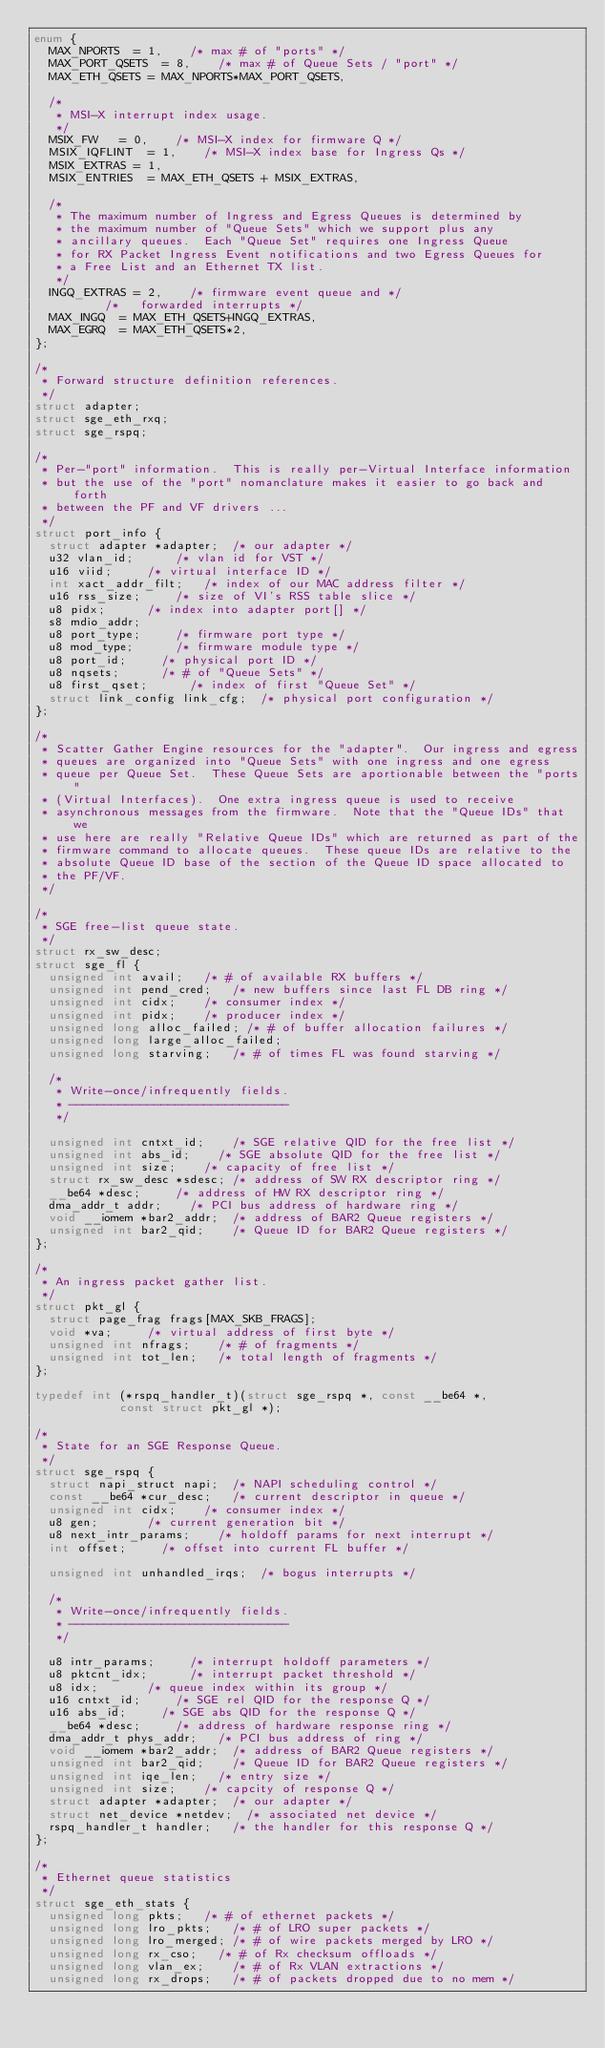Convert code to text. <code><loc_0><loc_0><loc_500><loc_500><_C_>enum {
	MAX_NPORTS	= 1,		/* max # of "ports" */
	MAX_PORT_QSETS	= 8,		/* max # of Queue Sets / "port" */
	MAX_ETH_QSETS	= MAX_NPORTS*MAX_PORT_QSETS,

	/*
	 * MSI-X interrupt index usage.
	 */
	MSIX_FW		= 0,		/* MSI-X index for firmware Q */
	MSIX_IQFLINT	= 1,		/* MSI-X index base for Ingress Qs */
	MSIX_EXTRAS	= 1,
	MSIX_ENTRIES	= MAX_ETH_QSETS + MSIX_EXTRAS,

	/*
	 * The maximum number of Ingress and Egress Queues is determined by
	 * the maximum number of "Queue Sets" which we support plus any
	 * ancillary queues.  Each "Queue Set" requires one Ingress Queue
	 * for RX Packet Ingress Event notifications and two Egress Queues for
	 * a Free List and an Ethernet TX list.
	 */
	INGQ_EXTRAS	= 2,		/* firmware event queue and */
					/*   forwarded interrupts */
	MAX_INGQ	= MAX_ETH_QSETS+INGQ_EXTRAS,
	MAX_EGRQ	= MAX_ETH_QSETS*2,
};

/*
 * Forward structure definition references.
 */
struct adapter;
struct sge_eth_rxq;
struct sge_rspq;

/*
 * Per-"port" information.  This is really per-Virtual Interface information
 * but the use of the "port" nomanclature makes it easier to go back and forth
 * between the PF and VF drivers ...
 */
struct port_info {
	struct adapter *adapter;	/* our adapter */
	u32 vlan_id;			/* vlan id for VST */
	u16 viid;			/* virtual interface ID */
	int xact_addr_filt;		/* index of our MAC address filter */
	u16 rss_size;			/* size of VI's RSS table slice */
	u8 pidx;			/* index into adapter port[] */
	s8 mdio_addr;
	u8 port_type;			/* firmware port type */
	u8 mod_type;			/* firmware module type */
	u8 port_id;			/* physical port ID */
	u8 nqsets;			/* # of "Queue Sets" */
	u8 first_qset;			/* index of first "Queue Set" */
	struct link_config link_cfg;	/* physical port configuration */
};

/*
 * Scatter Gather Engine resources for the "adapter".  Our ingress and egress
 * queues are organized into "Queue Sets" with one ingress and one egress
 * queue per Queue Set.  These Queue Sets are aportionable between the "ports"
 * (Virtual Interfaces).  One extra ingress queue is used to receive
 * asynchronous messages from the firmware.  Note that the "Queue IDs" that we
 * use here are really "Relative Queue IDs" which are returned as part of the
 * firmware command to allocate queues.  These queue IDs are relative to the
 * absolute Queue ID base of the section of the Queue ID space allocated to
 * the PF/VF.
 */

/*
 * SGE free-list queue state.
 */
struct rx_sw_desc;
struct sge_fl {
	unsigned int avail;		/* # of available RX buffers */
	unsigned int pend_cred;		/* new buffers since last FL DB ring */
	unsigned int cidx;		/* consumer index */
	unsigned int pidx;		/* producer index */
	unsigned long alloc_failed;	/* # of buffer allocation failures */
	unsigned long large_alloc_failed;
	unsigned long starving;		/* # of times FL was found starving */

	/*
	 * Write-once/infrequently fields.
	 * -------------------------------
	 */

	unsigned int cntxt_id;		/* SGE relative QID for the free list */
	unsigned int abs_id;		/* SGE absolute QID for the free list */
	unsigned int size;		/* capacity of free list */
	struct rx_sw_desc *sdesc;	/* address of SW RX descriptor ring */
	__be64 *desc;			/* address of HW RX descriptor ring */
	dma_addr_t addr;		/* PCI bus address of hardware ring */
	void __iomem *bar2_addr;	/* address of BAR2 Queue registers */
	unsigned int bar2_qid;		/* Queue ID for BAR2 Queue registers */
};

/*
 * An ingress packet gather list.
 */
struct pkt_gl {
	struct page_frag frags[MAX_SKB_FRAGS];
	void *va;			/* virtual address of first byte */
	unsigned int nfrags;		/* # of fragments */
	unsigned int tot_len;		/* total length of fragments */
};

typedef int (*rspq_handler_t)(struct sge_rspq *, const __be64 *,
			      const struct pkt_gl *);

/*
 * State for an SGE Response Queue.
 */
struct sge_rspq {
	struct napi_struct napi;	/* NAPI scheduling control */
	const __be64 *cur_desc;		/* current descriptor in queue */
	unsigned int cidx;		/* consumer index */
	u8 gen;				/* current generation bit */
	u8 next_intr_params;		/* holdoff params for next interrupt */
	int offset;			/* offset into current FL buffer */

	unsigned int unhandled_irqs;	/* bogus interrupts */

	/*
	 * Write-once/infrequently fields.
	 * -------------------------------
	 */

	u8 intr_params;			/* interrupt holdoff parameters */
	u8 pktcnt_idx;			/* interrupt packet threshold */
	u8 idx;				/* queue index within its group */
	u16 cntxt_id;			/* SGE rel QID for the response Q */
	u16 abs_id;			/* SGE abs QID for the response Q */
	__be64 *desc;			/* address of hardware response ring */
	dma_addr_t phys_addr;		/* PCI bus address of ring */
	void __iomem *bar2_addr;	/* address of BAR2 Queue registers */
	unsigned int bar2_qid;		/* Queue ID for BAR2 Queue registers */
	unsigned int iqe_len;		/* entry size */
	unsigned int size;		/* capcity of response Q */
	struct adapter *adapter;	/* our adapter */
	struct net_device *netdev;	/* associated net device */
	rspq_handler_t handler;		/* the handler for this response Q */
};

/*
 * Ethernet queue statistics
 */
struct sge_eth_stats {
	unsigned long pkts;		/* # of ethernet packets */
	unsigned long lro_pkts;		/* # of LRO super packets */
	unsigned long lro_merged;	/* # of wire packets merged by LRO */
	unsigned long rx_cso;		/* # of Rx checksum offloads */
	unsigned long vlan_ex;		/* # of Rx VLAN extractions */
	unsigned long rx_drops;		/* # of packets dropped due to no mem */</code> 